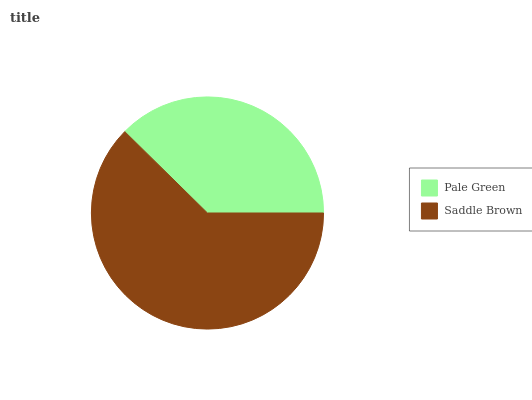Is Pale Green the minimum?
Answer yes or no. Yes. Is Saddle Brown the maximum?
Answer yes or no. Yes. Is Saddle Brown the minimum?
Answer yes or no. No. Is Saddle Brown greater than Pale Green?
Answer yes or no. Yes. Is Pale Green less than Saddle Brown?
Answer yes or no. Yes. Is Pale Green greater than Saddle Brown?
Answer yes or no. No. Is Saddle Brown less than Pale Green?
Answer yes or no. No. Is Saddle Brown the high median?
Answer yes or no. Yes. Is Pale Green the low median?
Answer yes or no. Yes. Is Pale Green the high median?
Answer yes or no. No. Is Saddle Brown the low median?
Answer yes or no. No. 